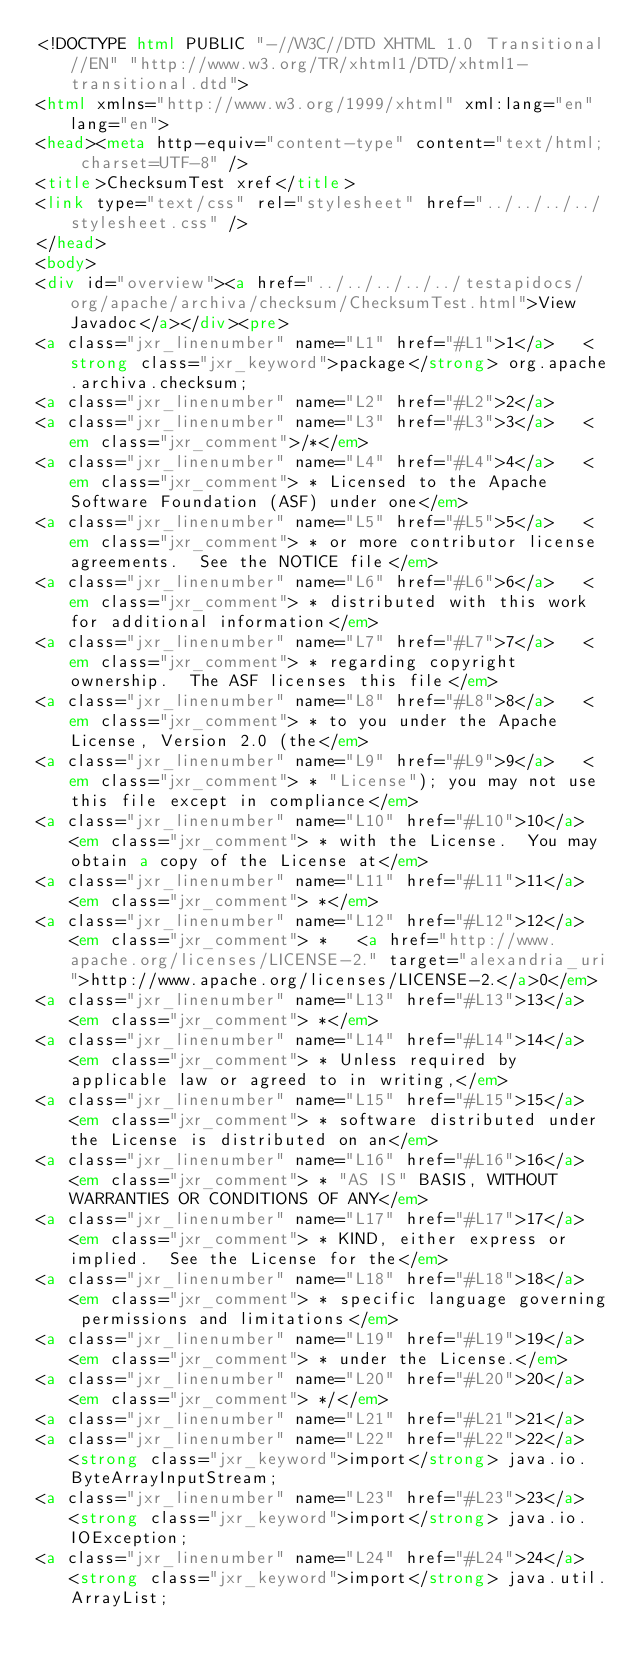<code> <loc_0><loc_0><loc_500><loc_500><_HTML_><!DOCTYPE html PUBLIC "-//W3C//DTD XHTML 1.0 Transitional//EN" "http://www.w3.org/TR/xhtml1/DTD/xhtml1-transitional.dtd">
<html xmlns="http://www.w3.org/1999/xhtml" xml:lang="en" lang="en">
<head><meta http-equiv="content-type" content="text/html; charset=UTF-8" />
<title>ChecksumTest xref</title>
<link type="text/css" rel="stylesheet" href="../../../../stylesheet.css" />
</head>
<body>
<div id="overview"><a href="../../../../../testapidocs/org/apache/archiva/checksum/ChecksumTest.html">View Javadoc</a></div><pre>
<a class="jxr_linenumber" name="L1" href="#L1">1</a>   <strong class="jxr_keyword">package</strong> org.apache.archiva.checksum;
<a class="jxr_linenumber" name="L2" href="#L2">2</a>   
<a class="jxr_linenumber" name="L3" href="#L3">3</a>   <em class="jxr_comment">/*</em>
<a class="jxr_linenumber" name="L4" href="#L4">4</a>   <em class="jxr_comment"> * Licensed to the Apache Software Foundation (ASF) under one</em>
<a class="jxr_linenumber" name="L5" href="#L5">5</a>   <em class="jxr_comment"> * or more contributor license agreements.  See the NOTICE file</em>
<a class="jxr_linenumber" name="L6" href="#L6">6</a>   <em class="jxr_comment"> * distributed with this work for additional information</em>
<a class="jxr_linenumber" name="L7" href="#L7">7</a>   <em class="jxr_comment"> * regarding copyright ownership.  The ASF licenses this file</em>
<a class="jxr_linenumber" name="L8" href="#L8">8</a>   <em class="jxr_comment"> * to you under the Apache License, Version 2.0 (the</em>
<a class="jxr_linenumber" name="L9" href="#L9">9</a>   <em class="jxr_comment"> * "License"); you may not use this file except in compliance</em>
<a class="jxr_linenumber" name="L10" href="#L10">10</a>  <em class="jxr_comment"> * with the License.  You may obtain a copy of the License at</em>
<a class="jxr_linenumber" name="L11" href="#L11">11</a>  <em class="jxr_comment"> *</em>
<a class="jxr_linenumber" name="L12" href="#L12">12</a>  <em class="jxr_comment"> *   <a href="http://www.apache.org/licenses/LICENSE-2." target="alexandria_uri">http://www.apache.org/licenses/LICENSE-2.</a>0</em>
<a class="jxr_linenumber" name="L13" href="#L13">13</a>  <em class="jxr_comment"> *</em>
<a class="jxr_linenumber" name="L14" href="#L14">14</a>  <em class="jxr_comment"> * Unless required by applicable law or agreed to in writing,</em>
<a class="jxr_linenumber" name="L15" href="#L15">15</a>  <em class="jxr_comment"> * software distributed under the License is distributed on an</em>
<a class="jxr_linenumber" name="L16" href="#L16">16</a>  <em class="jxr_comment"> * "AS IS" BASIS, WITHOUT WARRANTIES OR CONDITIONS OF ANY</em>
<a class="jxr_linenumber" name="L17" href="#L17">17</a>  <em class="jxr_comment"> * KIND, either express or implied.  See the License for the</em>
<a class="jxr_linenumber" name="L18" href="#L18">18</a>  <em class="jxr_comment"> * specific language governing permissions and limitations</em>
<a class="jxr_linenumber" name="L19" href="#L19">19</a>  <em class="jxr_comment"> * under the License.</em>
<a class="jxr_linenumber" name="L20" href="#L20">20</a>  <em class="jxr_comment"> */</em>
<a class="jxr_linenumber" name="L21" href="#L21">21</a>  
<a class="jxr_linenumber" name="L22" href="#L22">22</a>  <strong class="jxr_keyword">import</strong> java.io.ByteArrayInputStream;
<a class="jxr_linenumber" name="L23" href="#L23">23</a>  <strong class="jxr_keyword">import</strong> java.io.IOException;
<a class="jxr_linenumber" name="L24" href="#L24">24</a>  <strong class="jxr_keyword">import</strong> java.util.ArrayList;</code> 